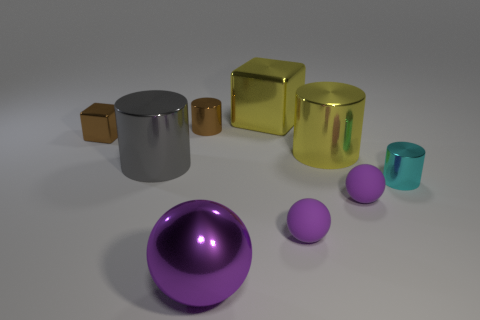There is a small shiny thing right of the large ball; is its shape the same as the metal thing in front of the cyan cylinder?
Your answer should be very brief. No. There is a block that is the same size as the cyan shiny cylinder; what is it made of?
Make the answer very short. Metal. Is the small cylinder behind the small cyan cylinder made of the same material as the yellow object that is behind the brown block?
Give a very brief answer. Yes. What is the shape of the cyan object that is the same size as the brown block?
Ensure brevity in your answer.  Cylinder. How many other things are the same color as the tiny cube?
Make the answer very short. 1. There is a tiny cylinder that is right of the yellow shiny block; what color is it?
Provide a succinct answer. Cyan. How many other objects are there of the same material as the small brown cube?
Make the answer very short. 6. Is the number of small brown metallic cylinders that are right of the small block greater than the number of tiny purple objects right of the small cyan metal thing?
Give a very brief answer. Yes. How many small metallic cylinders are right of the yellow cube?
Your response must be concise. 1. Is the brown block made of the same material as the tiny ball that is right of the big yellow metal cylinder?
Give a very brief answer. No. 